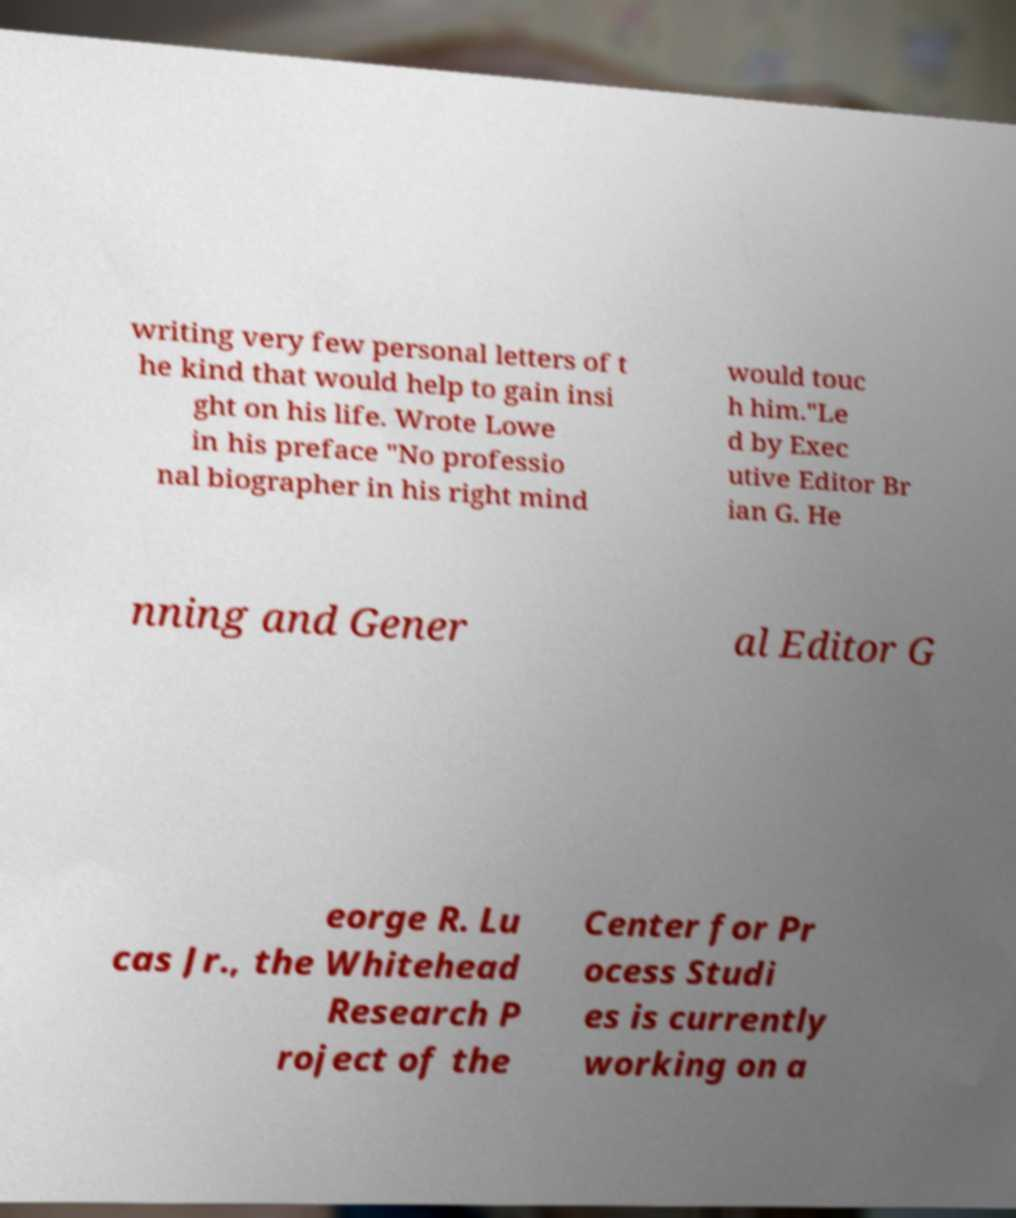Can you accurately transcribe the text from the provided image for me? writing very few personal letters of t he kind that would help to gain insi ght on his life. Wrote Lowe in his preface "No professio nal biographer in his right mind would touc h him."Le d by Exec utive Editor Br ian G. He nning and Gener al Editor G eorge R. Lu cas Jr., the Whitehead Research P roject of the Center for Pr ocess Studi es is currently working on a 